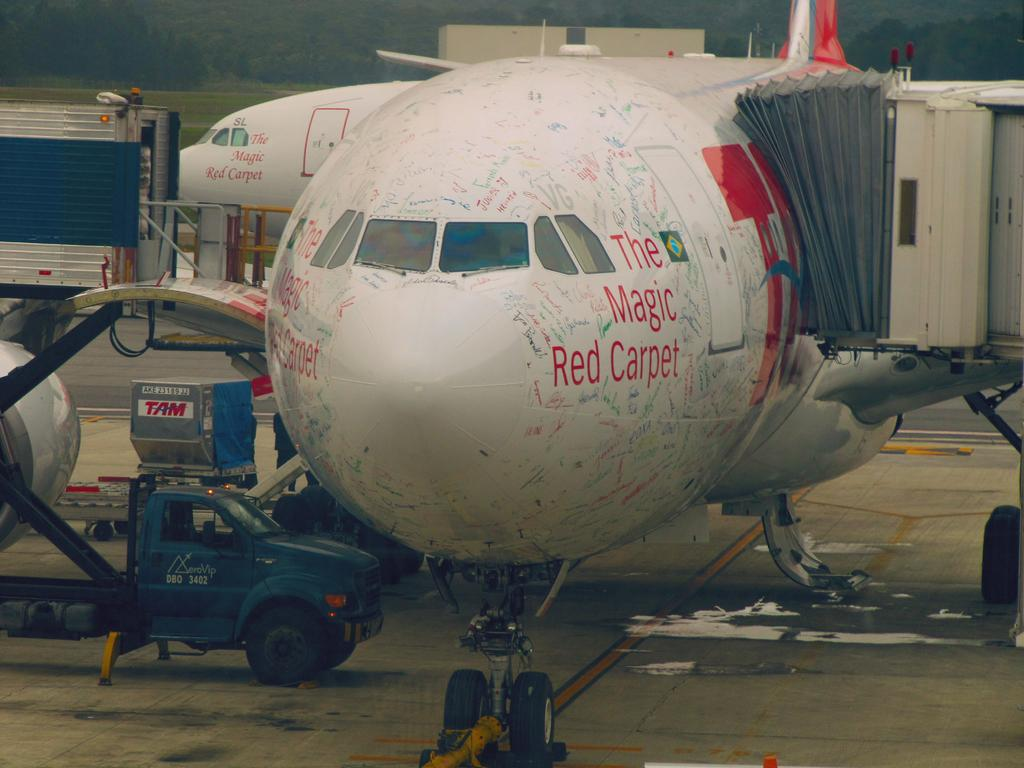<image>
Relay a brief, clear account of the picture shown. the magic red carpet plane has hand written words on it in different colors 